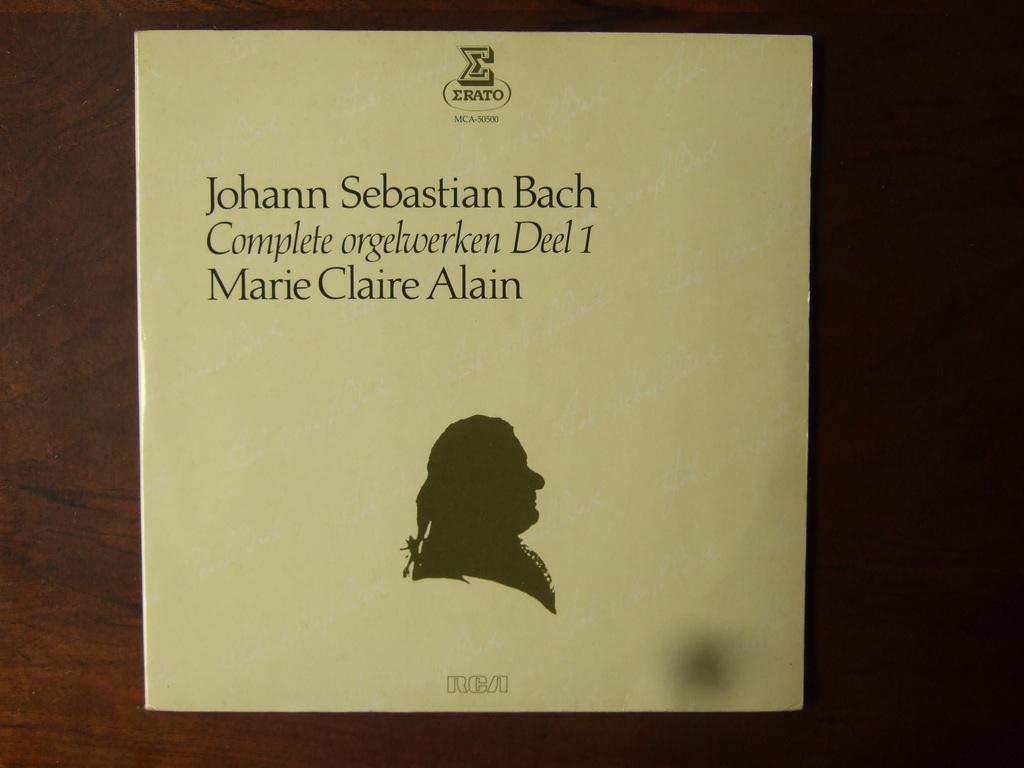Can you describe this image briefly? In this image I can see a paper and something is written on it. It is on the brown surface. 